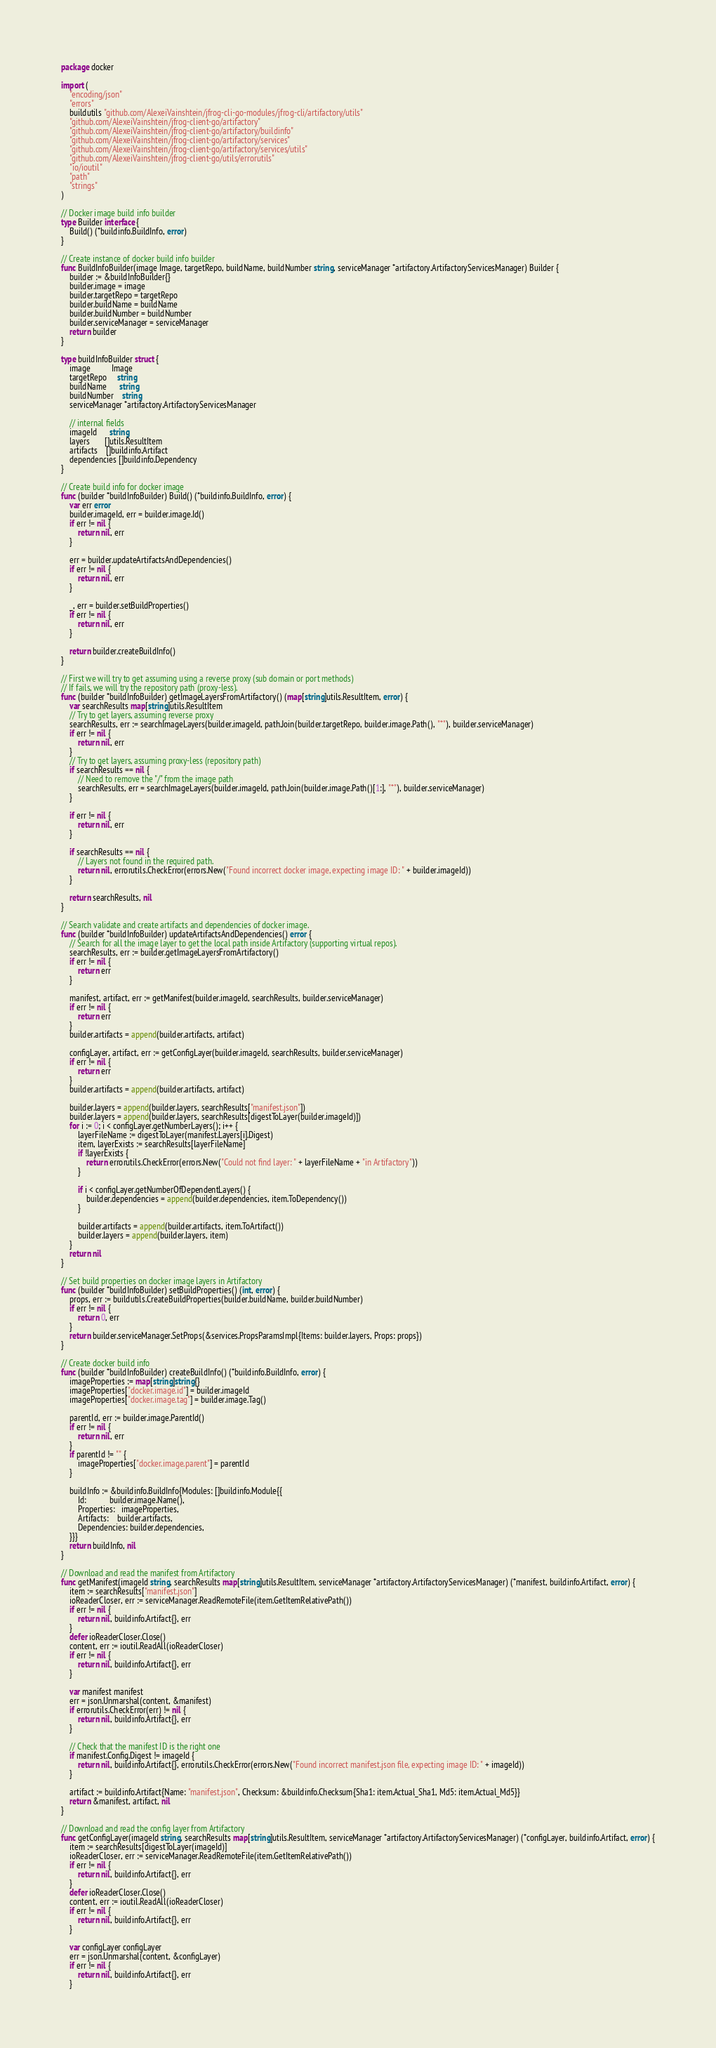<code> <loc_0><loc_0><loc_500><loc_500><_Go_>package docker

import (
	"encoding/json"
	"errors"
	buildutils "github.com/AlexeiVainshtein/jfrog-cli-go-modules/jfrog-cli/artifactory/utils"
	"github.com/AlexeiVainshtein/jfrog-client-go/artifactory"
	"github.com/AlexeiVainshtein/jfrog-client-go/artifactory/buildinfo"
	"github.com/AlexeiVainshtein/jfrog-client-go/artifactory/services"
	"github.com/AlexeiVainshtein/jfrog-client-go/artifactory/services/utils"
	"github.com/AlexeiVainshtein/jfrog-client-go/utils/errorutils"
	"io/ioutil"
	"path"
	"strings"
)

// Docker image build info builder
type Builder interface {
	Build() (*buildinfo.BuildInfo, error)
}

// Create instance of docker build info builder
func BuildInfoBuilder(image Image, targetRepo, buildName, buildNumber string, serviceManager *artifactory.ArtifactoryServicesManager) Builder {
	builder := &buildInfoBuilder{}
	builder.image = image
	builder.targetRepo = targetRepo
	builder.buildName = buildName
	builder.buildNumber = buildNumber
	builder.serviceManager = serviceManager
	return builder
}

type buildInfoBuilder struct {
	image          Image
	targetRepo     string
	buildName      string
	buildNumber    string
	serviceManager *artifactory.ArtifactoryServicesManager

	// internal fields
	imageId      string
	layers       []utils.ResultItem
	artifacts    []buildinfo.Artifact
	dependencies []buildinfo.Dependency
}

// Create build info for docker image
func (builder *buildInfoBuilder) Build() (*buildinfo.BuildInfo, error) {
	var err error
	builder.imageId, err = builder.image.Id()
	if err != nil {
		return nil, err
	}

	err = builder.updateArtifactsAndDependencies()
	if err != nil {
		return nil, err
	}

	_, err = builder.setBuildProperties()
	if err != nil {
		return nil, err
	}

	return builder.createBuildInfo()
}

// First we will try to get assuming using a reverse proxy (sub domain or port methods)
// If fails, we will try the repository path (proxy-less).
func (builder *buildInfoBuilder) getImageLayersFromArtifactory() (map[string]utils.ResultItem, error) {
	var searchResults map[string]utils.ResultItem
	// Try to get layers, assuming reverse proxy
	searchResults, err := searchImageLayers(builder.imageId, path.Join(builder.targetRepo, builder.image.Path(), "*"), builder.serviceManager)
	if err != nil {
		return nil, err
	}
	// Try to get layers, assuming proxy-less (repository path)
	if searchResults == nil {
		// Need to remove the "/" from the image path
		searchResults, err = searchImageLayers(builder.imageId, path.Join(builder.image.Path()[1:], "*"), builder.serviceManager)
	}

	if err != nil {
		return nil, err
	}

	if searchResults == nil {
		// Layers not found in the required path.
		return nil, errorutils.CheckError(errors.New("Found incorrect docker image, expecting image ID: " + builder.imageId))
	}

	return searchResults, nil
}

// Search validate and create artifacts and dependencies of docker image.
func (builder *buildInfoBuilder) updateArtifactsAndDependencies() error {
	// Search for all the image layer to get the local path inside Artifactory (supporting virtual repos).
	searchResults, err := builder.getImageLayersFromArtifactory()
	if err != nil {
		return err
	}

	manifest, artifact, err := getManifest(builder.imageId, searchResults, builder.serviceManager)
	if err != nil {
		return err
	}
	builder.artifacts = append(builder.artifacts, artifact)

	configLayer, artifact, err := getConfigLayer(builder.imageId, searchResults, builder.serviceManager)
	if err != nil {
		return err
	}
	builder.artifacts = append(builder.artifacts, artifact)

	builder.layers = append(builder.layers, searchResults["manifest.json"])
	builder.layers = append(builder.layers, searchResults[digestToLayer(builder.imageId)])
	for i := 0; i < configLayer.getNumberLayers(); i++ {
		layerFileName := digestToLayer(manifest.Layers[i].Digest)
		item, layerExists := searchResults[layerFileName]
		if !layerExists {
			return errorutils.CheckError(errors.New("Could not find layer: " + layerFileName + "in Artifactory"))
		}

		if i < configLayer.getNumberOfDependentLayers() {
			builder.dependencies = append(builder.dependencies, item.ToDependency())
		}

		builder.artifacts = append(builder.artifacts, item.ToArtifact())
		builder.layers = append(builder.layers, item)
	}
	return nil
}

// Set build properties on docker image layers in Artifactory
func (builder *buildInfoBuilder) setBuildProperties() (int, error) {
	props, err := buildutils.CreateBuildProperties(builder.buildName, builder.buildNumber)
	if err != nil {
		return 0, err
	}
	return builder.serviceManager.SetProps(&services.PropsParamsImpl{Items: builder.layers, Props: props})
}

// Create docker build info
func (builder *buildInfoBuilder) createBuildInfo() (*buildinfo.BuildInfo, error) {
	imageProperties := map[string]string{}
	imageProperties["docker.image.id"] = builder.imageId
	imageProperties["docker.image.tag"] = builder.image.Tag()

	parentId, err := builder.image.ParentId()
	if err != nil {
		return nil, err
	}
	if parentId != "" {
		imageProperties["docker.image.parent"] = parentId
	}

	buildInfo := &buildinfo.BuildInfo{Modules: []buildinfo.Module{{
		Id:           builder.image.Name(),
		Properties:   imageProperties,
		Artifacts:    builder.artifacts,
		Dependencies: builder.dependencies,
	}}}
	return buildInfo, nil
}

// Download and read the manifest from Artifactory
func getManifest(imageId string, searchResults map[string]utils.ResultItem, serviceManager *artifactory.ArtifactoryServicesManager) (*manifest, buildinfo.Artifact, error) {
	item := searchResults["manifest.json"]
	ioReaderCloser, err := serviceManager.ReadRemoteFile(item.GetItemRelativePath())
	if err != nil {
		return nil, buildinfo.Artifact{}, err
	}
	defer ioReaderCloser.Close()
	content, err := ioutil.ReadAll(ioReaderCloser)
	if err != nil {
		return nil, buildinfo.Artifact{}, err
	}

	var manifest manifest
	err = json.Unmarshal(content, &manifest)
	if errorutils.CheckError(err) != nil {
		return nil, buildinfo.Artifact{}, err
	}

	// Check that the manifest ID is the right one
	if manifest.Config.Digest != imageId {
		return nil, buildinfo.Artifact{}, errorutils.CheckError(errors.New("Found incorrect manifest.json file, expecting image ID: " + imageId))
	}

	artifact := buildinfo.Artifact{Name: "manifest.json", Checksum: &buildinfo.Checksum{Sha1: item.Actual_Sha1, Md5: item.Actual_Md5}}
	return &manifest, artifact, nil
}

// Download and read the config layer from Artifactory
func getConfigLayer(imageId string, searchResults map[string]utils.ResultItem, serviceManager *artifactory.ArtifactoryServicesManager) (*configLayer, buildinfo.Artifact, error) {
	item := searchResults[digestToLayer(imageId)]
	ioReaderCloser, err := serviceManager.ReadRemoteFile(item.GetItemRelativePath())
	if err != nil {
		return nil, buildinfo.Artifact{}, err
	}
	defer ioReaderCloser.Close()
	content, err := ioutil.ReadAll(ioReaderCloser)
	if err != nil {
		return nil, buildinfo.Artifact{}, err
	}

	var configLayer configLayer
	err = json.Unmarshal(content, &configLayer)
	if err != nil {
		return nil, buildinfo.Artifact{}, err
	}
</code> 